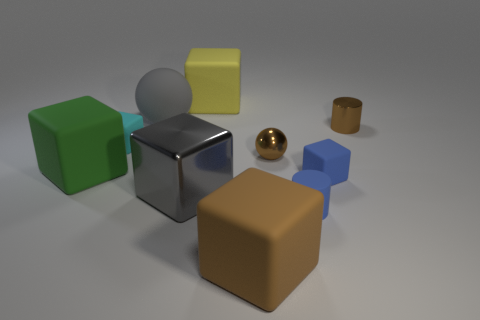There is a big matte thing left of the cyan matte block that is on the right side of the large green object; how many large green matte things are in front of it?
Offer a very short reply. 0. Do the brown metal object that is right of the blue cube and the yellow thing that is to the right of the large metal cube have the same shape?
Make the answer very short. No. What number of things are either tiny blue matte blocks or large rubber cubes?
Your answer should be very brief. 4. What is the gray thing that is in front of the gray thing that is behind the brown cylinder made of?
Your response must be concise. Metal. Are there any big rubber cubes that have the same color as the small shiny cylinder?
Your answer should be compact. Yes. There is another cylinder that is the same size as the shiny cylinder; what is its color?
Your response must be concise. Blue. There is a brown object that is to the right of the small cylinder that is in front of the small brown shiny thing on the right side of the shiny ball; what is it made of?
Offer a terse response. Metal. Is the color of the matte sphere the same as the small cube that is on the right side of the tiny blue cylinder?
Provide a succinct answer. No. What number of things are things behind the big sphere or large rubber cubes in front of the cyan block?
Your answer should be compact. 3. What is the shape of the small brown shiny thing that is on the left side of the tiny matte cube right of the large matte ball?
Your answer should be very brief. Sphere. 